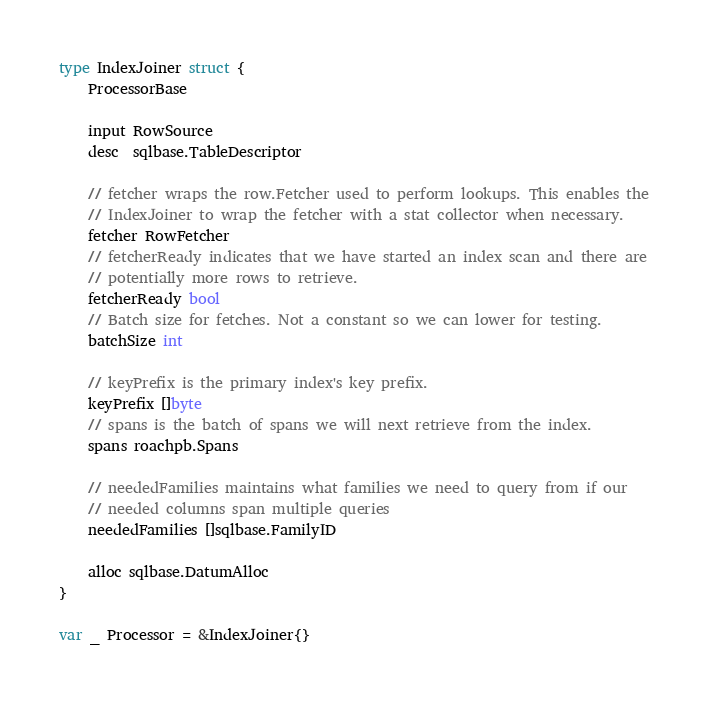Convert code to text. <code><loc_0><loc_0><loc_500><loc_500><_Go_>type IndexJoiner struct {
	ProcessorBase

	input RowSource
	desc  sqlbase.TableDescriptor

	// fetcher wraps the row.Fetcher used to perform lookups. This enables the
	// IndexJoiner to wrap the fetcher with a stat collector when necessary.
	fetcher RowFetcher
	// fetcherReady indicates that we have started an index scan and there are
	// potentially more rows to retrieve.
	fetcherReady bool
	// Batch size for fetches. Not a constant so we can lower for testing.
	batchSize int

	// keyPrefix is the primary index's key prefix.
	keyPrefix []byte
	// spans is the batch of spans we will next retrieve from the index.
	spans roachpb.Spans

	// neededFamilies maintains what families we need to query from if our
	// needed columns span multiple queries
	neededFamilies []sqlbase.FamilyID

	alloc sqlbase.DatumAlloc
}

var _ Processor = &IndexJoiner{}</code> 